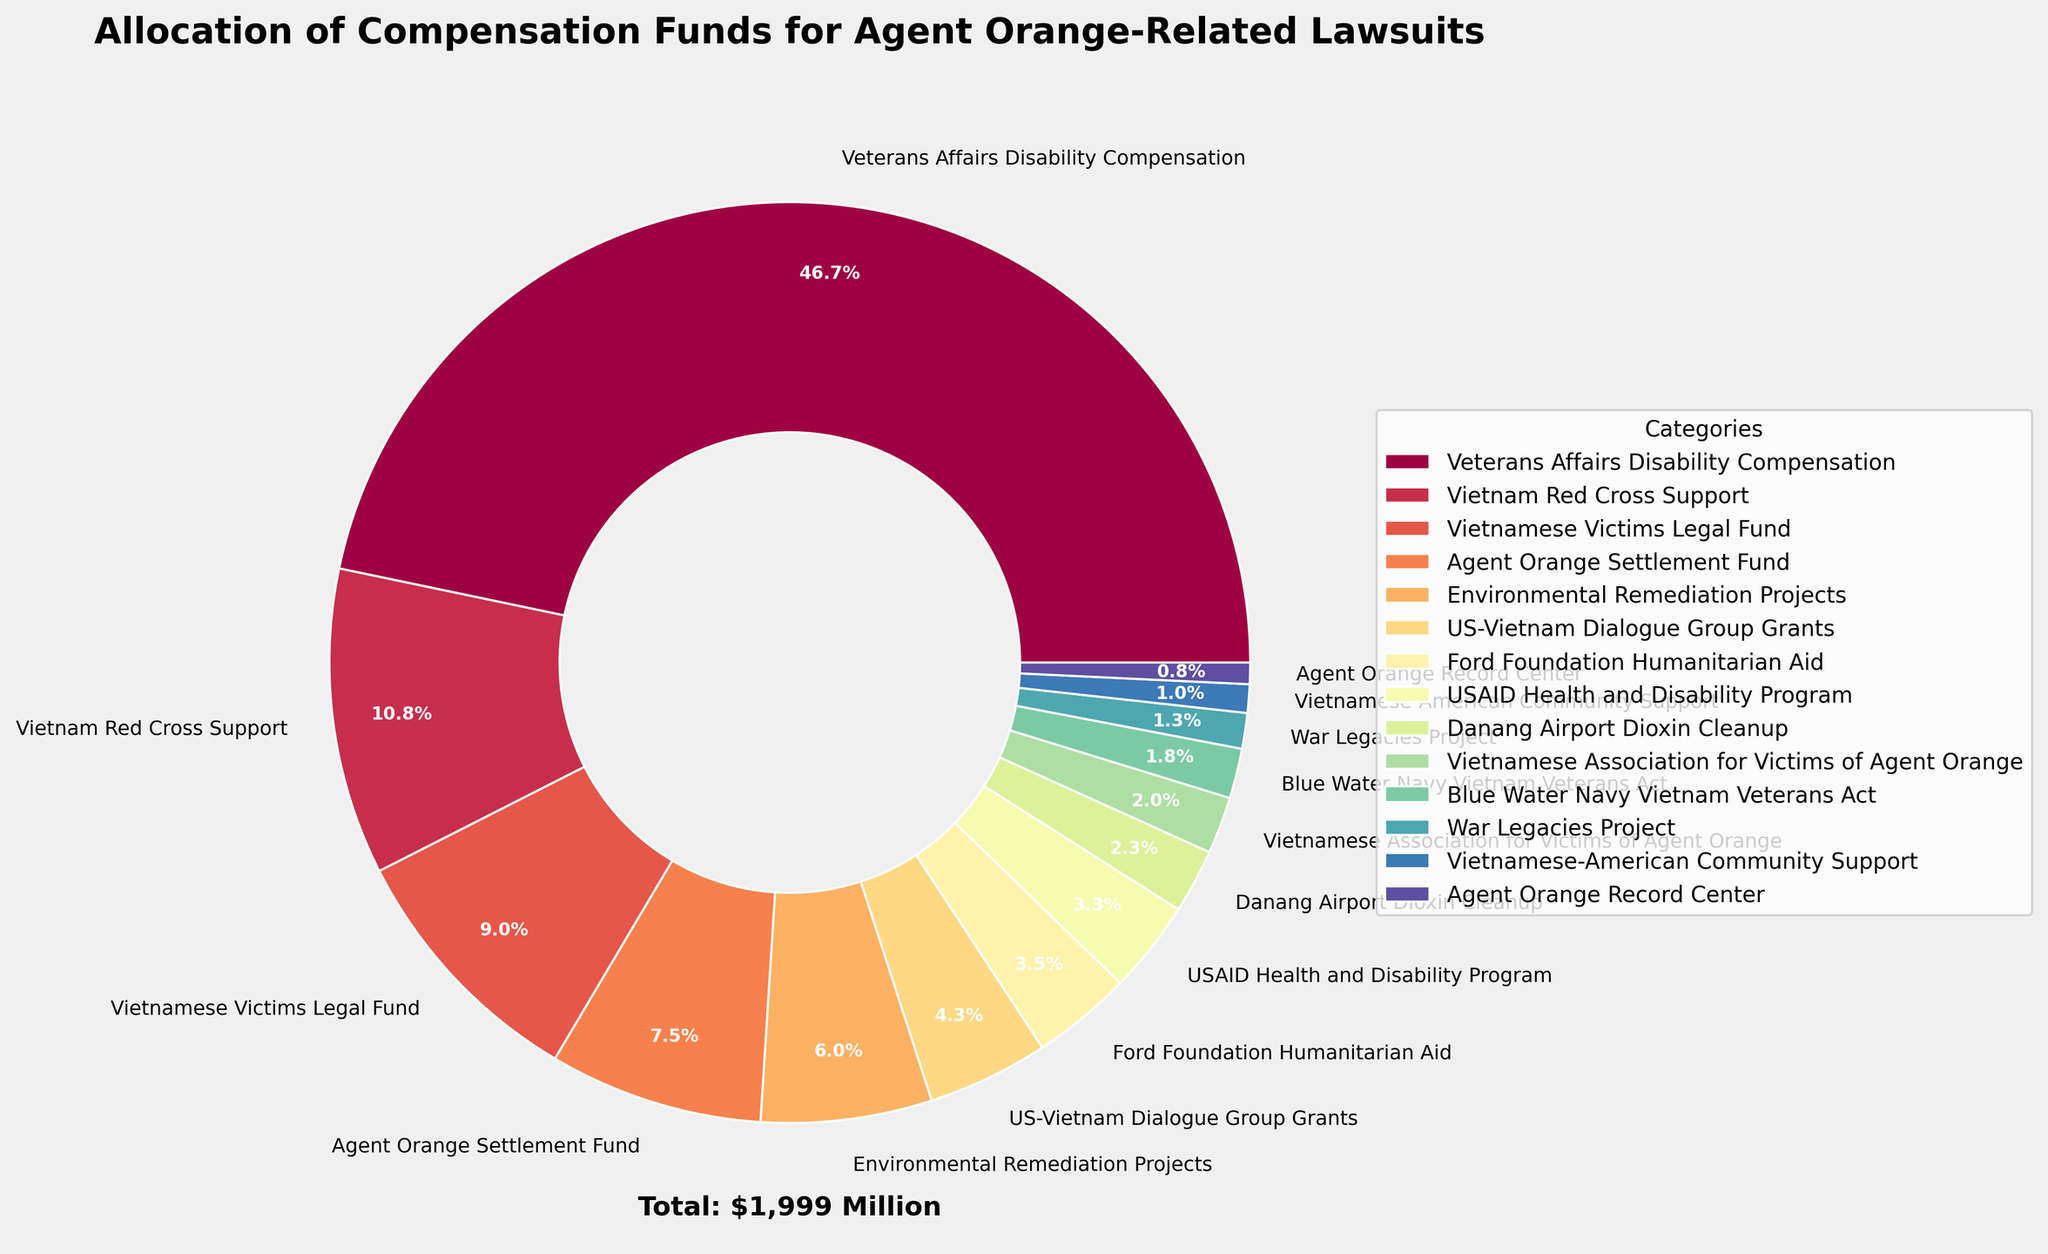Which category received the highest allocation? The largest section of the pie chart, visually taking up the most space, is labeled "Veterans Affairs Disability Compensation."
Answer: Veterans Affairs Disability Compensation What percentage of the total funds was allocated to the "Vietnam Red Cross Support"? On the pie chart, the label next to "Vietnam Red Cross Support" section shows the percentage.
Answer: 8.4% Which category has the smallest allocation and what is its value? Visually, the smallest section and its label on the pie chart correspond to the "Agent Orange Record Center." The amount is displayed in the legend.
Answer: Agent Orange Record Center, 15 million USD What is the combined allocation for "Environmental Remediation Projects" and "Danang Airport Dioxin Cleanup"? From the pie chart, sum the labeled amounts for "Environmental Remediation Projects" (120 million USD) and "Danang Airport Dioxin Cleanup" (45 million USD).
Answer: 165 million USD Is "Vietnamese Victims Legal Fund" allocated more funds than "US-Vietnam Dialogue Group Grants"? Compare the sizes of the pie sections and their labels for both categories. "Vietnamese Victims Legal Fund" is allocated 180 million USD whereas "US-Vietnam Dialogue Group Grants" is allocated 85 million USD.
Answer: Yes What portion of the total funds is allocated to the "Agent Orange Settlement Fund"? The pie chart section labeled "Agent Orange Settlement Fund" shows a percentage figure next to it.
Answer: 5.8% How much more funding does "Vietnamese Victims Legal Fund" receive compared to "Ford Foundation Humanitarian Aid"? Subtract the amount allocated to "Ford Foundation Humanitarian Aid" (70 million USD) from "Vietnamese Victims Legal Fund" (180 million USD).
Answer: 110 million USD What is the allocation difference between the highest-funded and lowest-funded categories? Subtract the amount allocated to "Agent Orange Record Center" (15 million USD) from "Veterans Affairs Disability Compensation" (934 million USD).
Answer: 919 million USD 